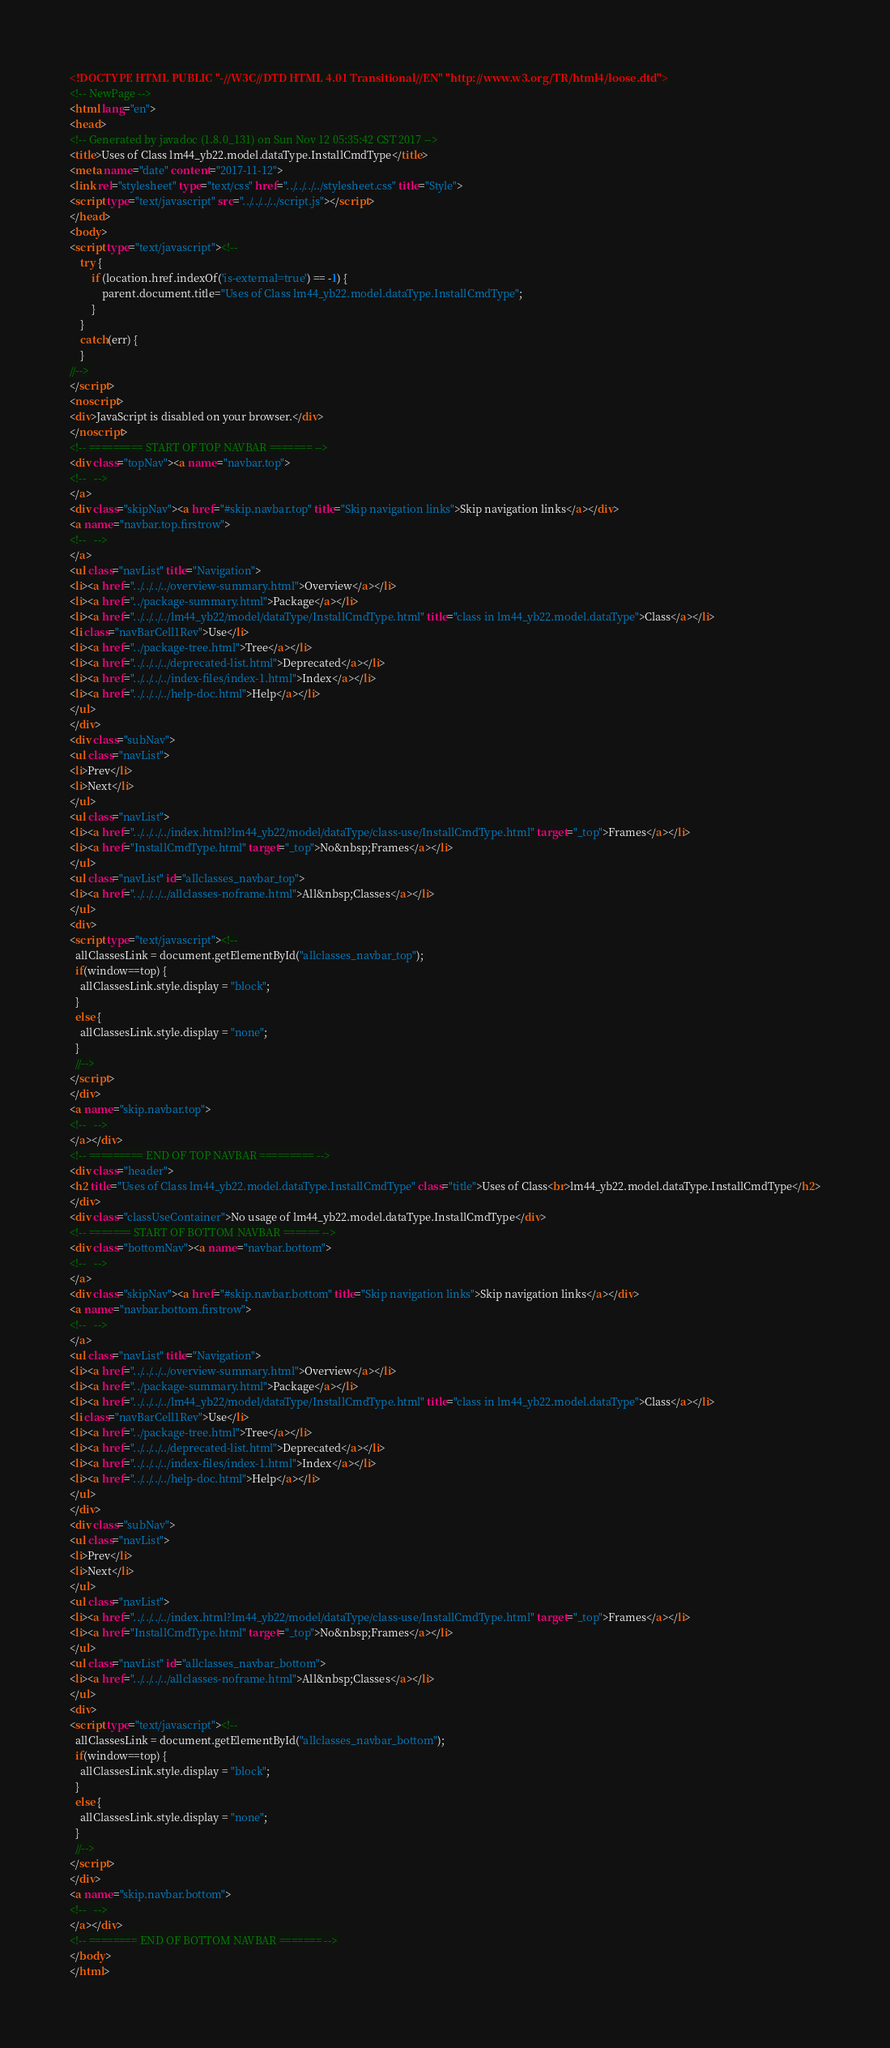Convert code to text. <code><loc_0><loc_0><loc_500><loc_500><_HTML_><!DOCTYPE HTML PUBLIC "-//W3C//DTD HTML 4.01 Transitional//EN" "http://www.w3.org/TR/html4/loose.dtd">
<!-- NewPage -->
<html lang="en">
<head>
<!-- Generated by javadoc (1.8.0_131) on Sun Nov 12 05:35:42 CST 2017 -->
<title>Uses of Class lm44_yb22.model.dataType.InstallCmdType</title>
<meta name="date" content="2017-11-12">
<link rel="stylesheet" type="text/css" href="../../../../stylesheet.css" title="Style">
<script type="text/javascript" src="../../../../script.js"></script>
</head>
<body>
<script type="text/javascript"><!--
    try {
        if (location.href.indexOf('is-external=true') == -1) {
            parent.document.title="Uses of Class lm44_yb22.model.dataType.InstallCmdType";
        }
    }
    catch(err) {
    }
//-->
</script>
<noscript>
<div>JavaScript is disabled on your browser.</div>
</noscript>
<!-- ========= START OF TOP NAVBAR ======= -->
<div class="topNav"><a name="navbar.top">
<!--   -->
</a>
<div class="skipNav"><a href="#skip.navbar.top" title="Skip navigation links">Skip navigation links</a></div>
<a name="navbar.top.firstrow">
<!--   -->
</a>
<ul class="navList" title="Navigation">
<li><a href="../../../../overview-summary.html">Overview</a></li>
<li><a href="../package-summary.html">Package</a></li>
<li><a href="../../../../lm44_yb22/model/dataType/InstallCmdType.html" title="class in lm44_yb22.model.dataType">Class</a></li>
<li class="navBarCell1Rev">Use</li>
<li><a href="../package-tree.html">Tree</a></li>
<li><a href="../../../../deprecated-list.html">Deprecated</a></li>
<li><a href="../../../../index-files/index-1.html">Index</a></li>
<li><a href="../../../../help-doc.html">Help</a></li>
</ul>
</div>
<div class="subNav">
<ul class="navList">
<li>Prev</li>
<li>Next</li>
</ul>
<ul class="navList">
<li><a href="../../../../index.html?lm44_yb22/model/dataType/class-use/InstallCmdType.html" target="_top">Frames</a></li>
<li><a href="InstallCmdType.html" target="_top">No&nbsp;Frames</a></li>
</ul>
<ul class="navList" id="allclasses_navbar_top">
<li><a href="../../../../allclasses-noframe.html">All&nbsp;Classes</a></li>
</ul>
<div>
<script type="text/javascript"><!--
  allClassesLink = document.getElementById("allclasses_navbar_top");
  if(window==top) {
    allClassesLink.style.display = "block";
  }
  else {
    allClassesLink.style.display = "none";
  }
  //-->
</script>
</div>
<a name="skip.navbar.top">
<!--   -->
</a></div>
<!-- ========= END OF TOP NAVBAR ========= -->
<div class="header">
<h2 title="Uses of Class lm44_yb22.model.dataType.InstallCmdType" class="title">Uses of Class<br>lm44_yb22.model.dataType.InstallCmdType</h2>
</div>
<div class="classUseContainer">No usage of lm44_yb22.model.dataType.InstallCmdType</div>
<!-- ======= START OF BOTTOM NAVBAR ====== -->
<div class="bottomNav"><a name="navbar.bottom">
<!--   -->
</a>
<div class="skipNav"><a href="#skip.navbar.bottom" title="Skip navigation links">Skip navigation links</a></div>
<a name="navbar.bottom.firstrow">
<!--   -->
</a>
<ul class="navList" title="Navigation">
<li><a href="../../../../overview-summary.html">Overview</a></li>
<li><a href="../package-summary.html">Package</a></li>
<li><a href="../../../../lm44_yb22/model/dataType/InstallCmdType.html" title="class in lm44_yb22.model.dataType">Class</a></li>
<li class="navBarCell1Rev">Use</li>
<li><a href="../package-tree.html">Tree</a></li>
<li><a href="../../../../deprecated-list.html">Deprecated</a></li>
<li><a href="../../../../index-files/index-1.html">Index</a></li>
<li><a href="../../../../help-doc.html">Help</a></li>
</ul>
</div>
<div class="subNav">
<ul class="navList">
<li>Prev</li>
<li>Next</li>
</ul>
<ul class="navList">
<li><a href="../../../../index.html?lm44_yb22/model/dataType/class-use/InstallCmdType.html" target="_top">Frames</a></li>
<li><a href="InstallCmdType.html" target="_top">No&nbsp;Frames</a></li>
</ul>
<ul class="navList" id="allclasses_navbar_bottom">
<li><a href="../../../../allclasses-noframe.html">All&nbsp;Classes</a></li>
</ul>
<div>
<script type="text/javascript"><!--
  allClassesLink = document.getElementById("allclasses_navbar_bottom");
  if(window==top) {
    allClassesLink.style.display = "block";
  }
  else {
    allClassesLink.style.display = "none";
  }
  //-->
</script>
</div>
<a name="skip.navbar.bottom">
<!--   -->
</a></div>
<!-- ======== END OF BOTTOM NAVBAR ======= -->
</body>
</html>
</code> 